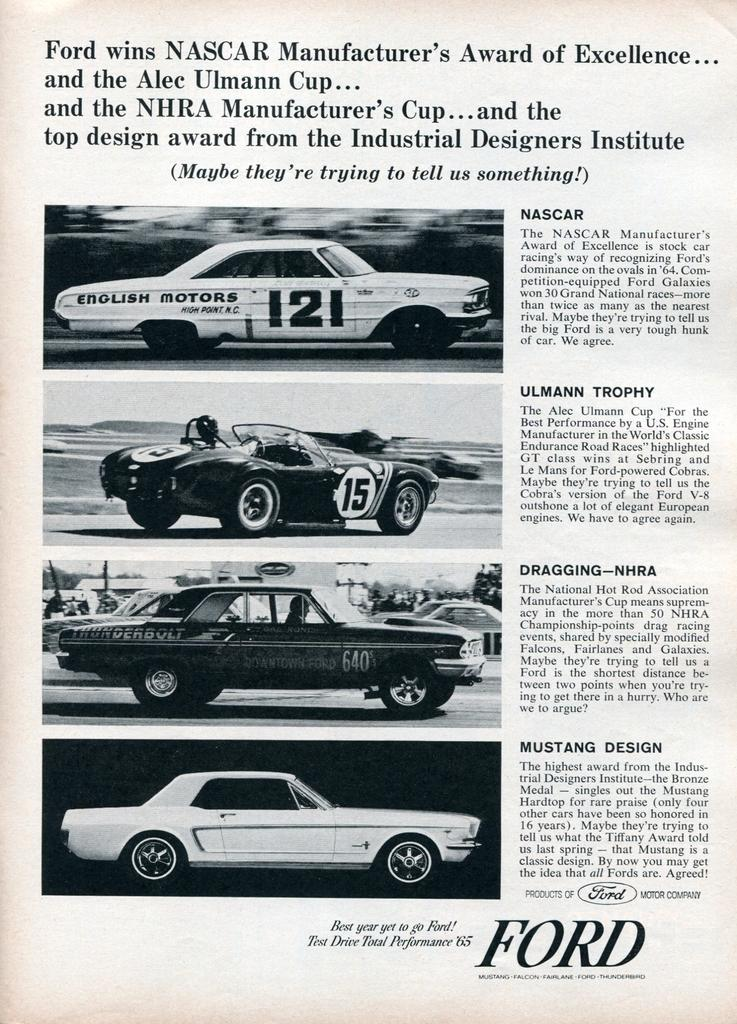What is the main subject of the paper in the image? The paper contains images of cars. Are there any additional elements on the paper besides the images of cars? Yes, there is writing on the paper. How many apples are hanging from the sky in the image? There are no apples present in the image, and the sky is not mentioned as a subject in the provided facts. 